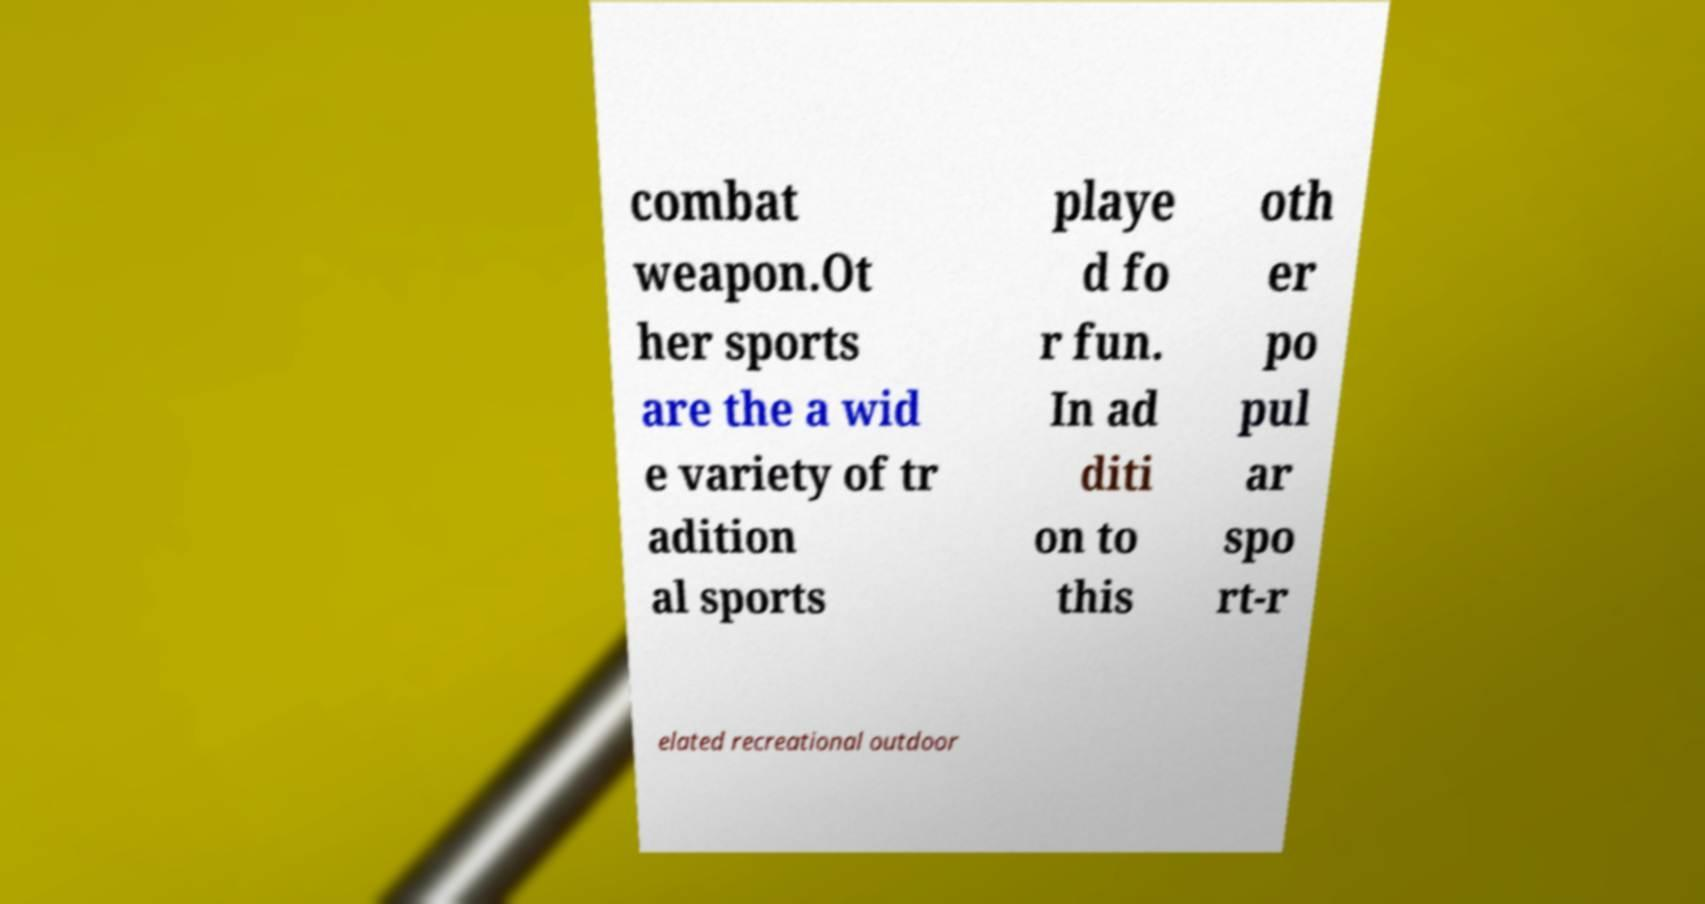What messages or text are displayed in this image? I need them in a readable, typed format. combat weapon.Ot her sports are the a wid e variety of tr adition al sports playe d fo r fun. In ad diti on to this oth er po pul ar spo rt-r elated recreational outdoor 